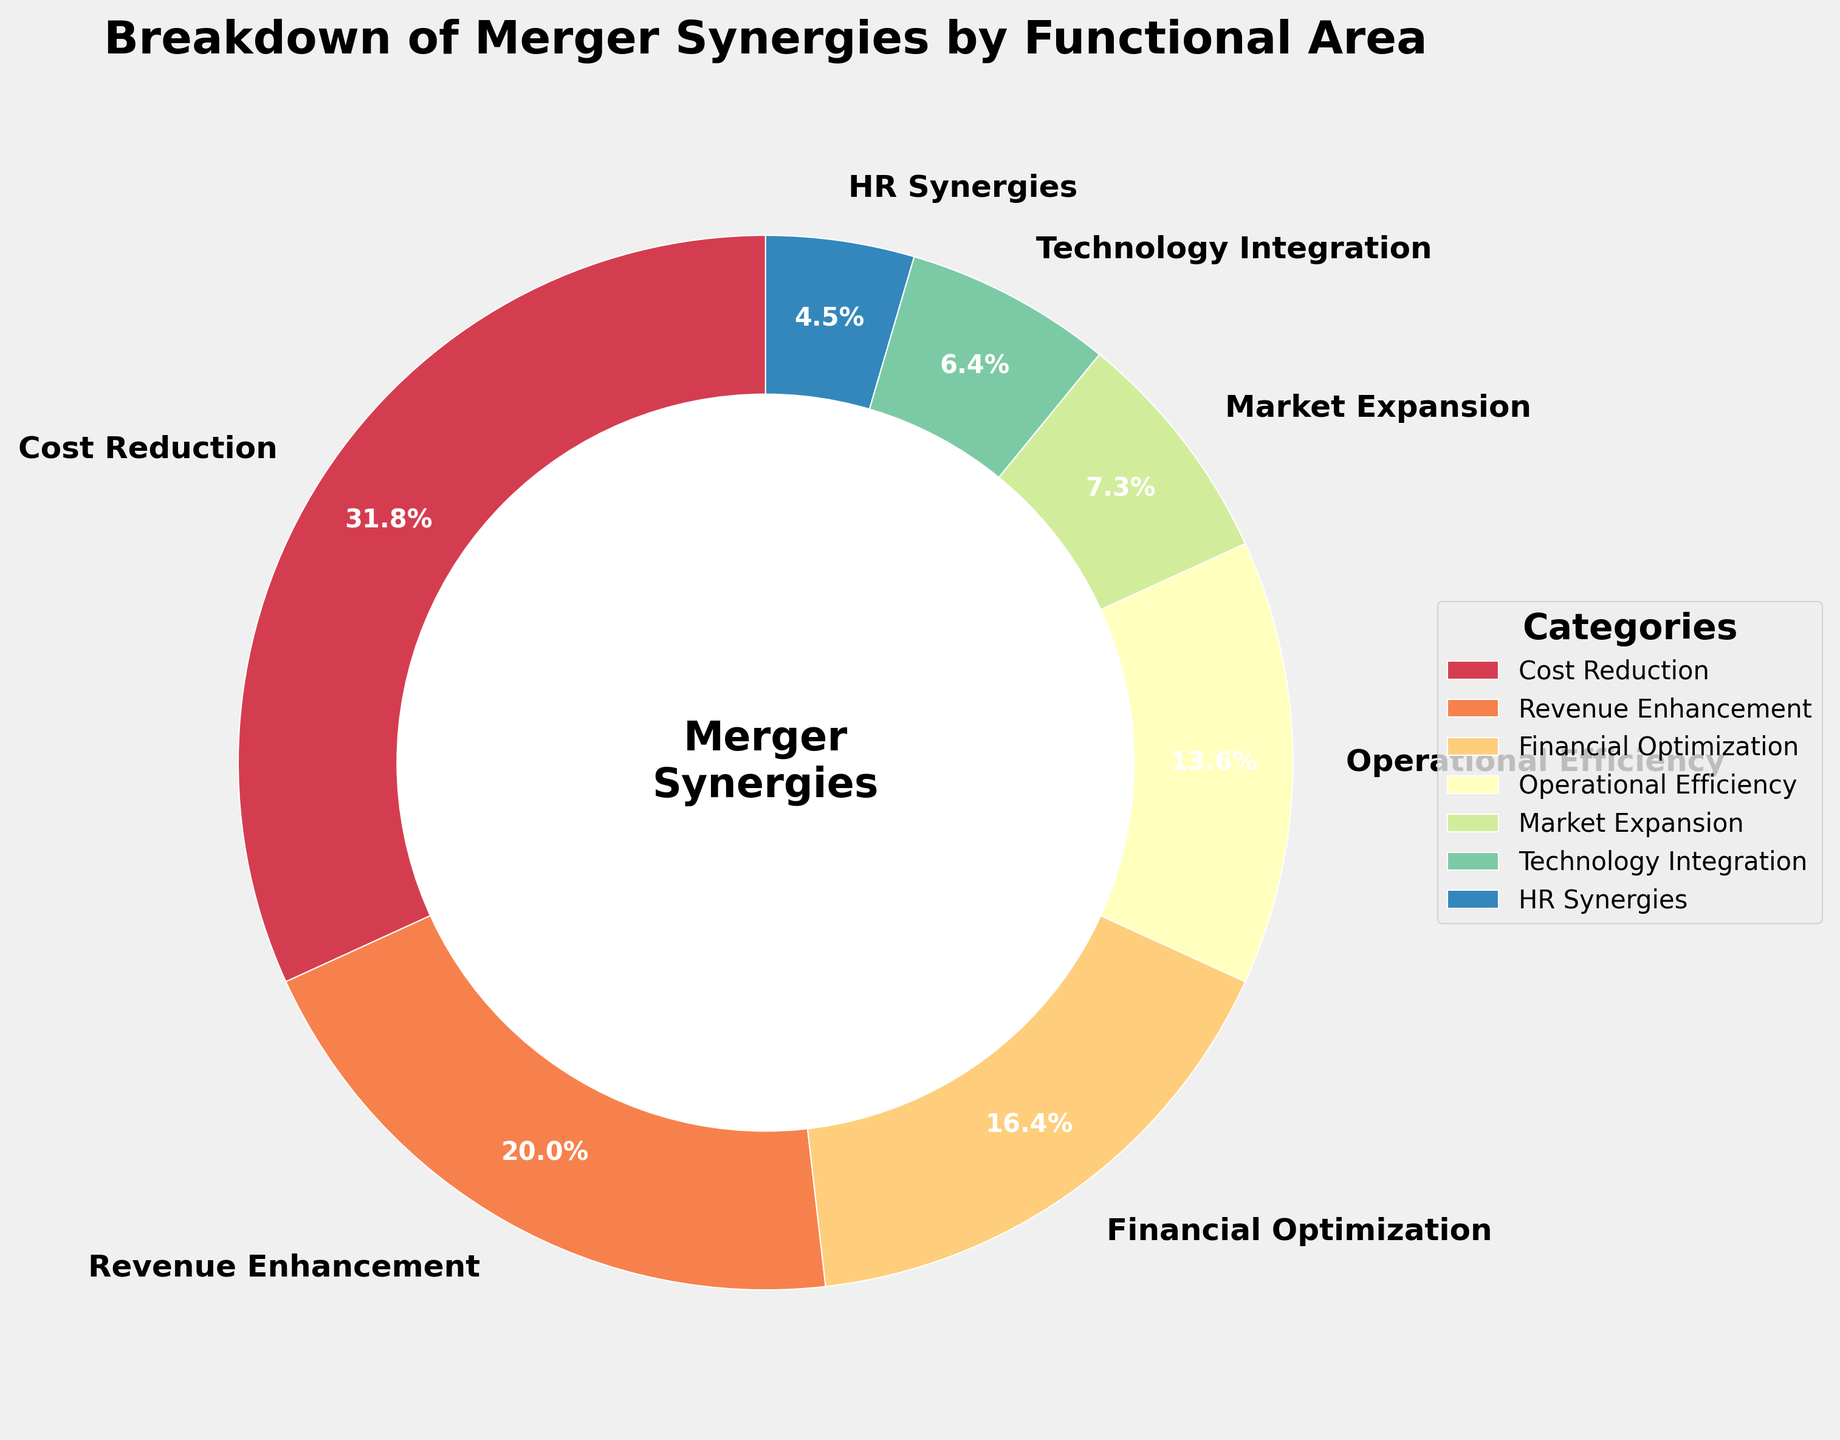Which category accounts for the largest percentage of merger synergies? The pie chart shows that "Cost Reduction" takes up the largest segment of the pie.
Answer: Cost Reduction What is the combined percentage of "Revenue Enhancement" and "Operational Efficiency"? According to the chart, "Revenue Enhancement" is 22% and "Operational Efficiency" is 15%. Adding these together gives 22% + 15% = 37%.
Answer: 37% Which category has the smallest representation in the pie chart? The smallest segment in the pie chart represents "HR Synergies" at 5%.
Answer: HR Synergies How does the percentage of "Technology Integration" compare to that of "Market Expansion"? "Technology Integration" is 7% and "Market Expansion" is 8%, so "Technology Integration" is 1% less than "Market Expansion".
Answer: Technology Integration is 1% less What is the total percentage represented by categories that individually contribute less than 10%? The relevant categories are "Market Expansion" (8%), "Technology Integration" (7%), and "HR Synergies" (5%). Summing these: 8% + 7% + 5% = 20%.
Answer: 20% How much more significant is "Cost Reduction" compared to "Financial Optimization"? "Cost Reduction" is 35% and "Financial Optimization" is 18%. The difference is 35% - 18% = 17%.
Answer: 17% Which category is represented by a color closer to red, "Cost Reduction" or "Market Expansion"? Visually, the pie chart shows "Cost Reduction" in a color closer to red than "Market Expansion".
Answer: Cost Reduction Is the percentage for "Operational Efficiency" more than double that for "HR Synergies"? "Operational Efficiency" is 15% and "HR Synergies" is 5%. Comparing these: 15% > 2*5% (10%) proves that it is more than double.
Answer: Yes What is the average percentage of the top three categories by percentage? The top three categories are "Cost Reduction" (35%), "Revenue Enhancement" (22%), and "Financial Optimization" (18%). Their sum is 35% + 22% + 18% = 75%, and the average is 75% / 3 = 25%.
Answer: 25% 